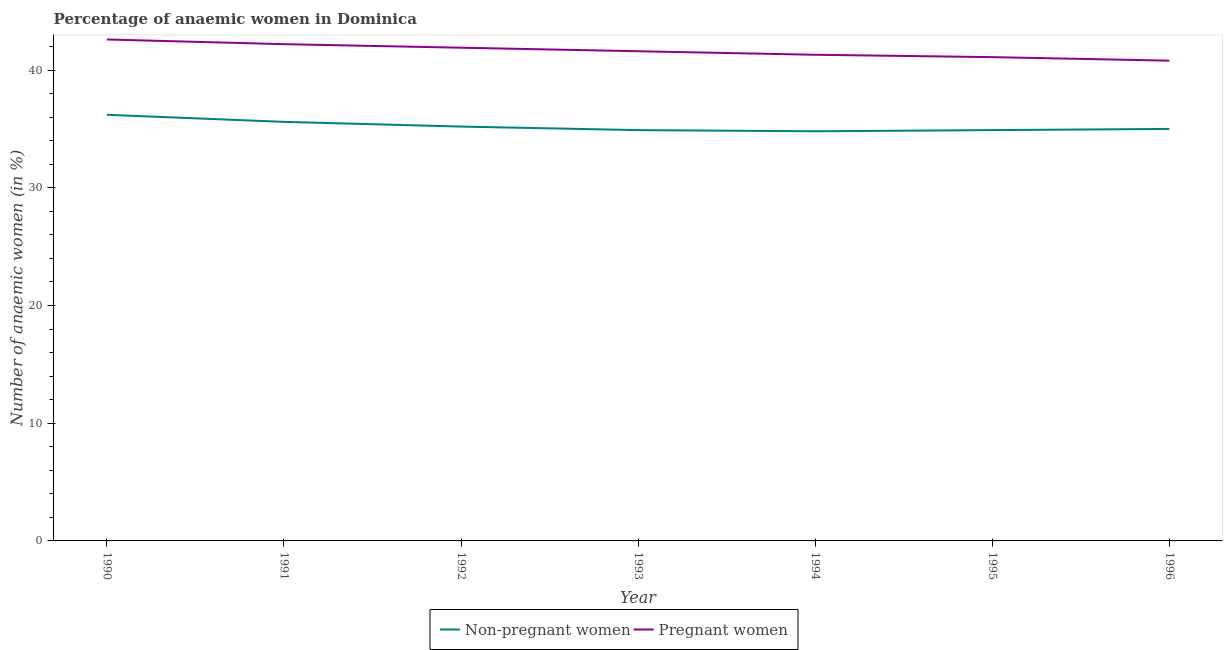How many different coloured lines are there?
Your response must be concise. 2. What is the percentage of pregnant anaemic women in 1991?
Provide a succinct answer. 42.2. Across all years, what is the maximum percentage of non-pregnant anaemic women?
Ensure brevity in your answer.  36.2. Across all years, what is the minimum percentage of non-pregnant anaemic women?
Give a very brief answer. 34.8. In which year was the percentage of non-pregnant anaemic women maximum?
Ensure brevity in your answer.  1990. In which year was the percentage of pregnant anaemic women minimum?
Your answer should be compact. 1996. What is the total percentage of pregnant anaemic women in the graph?
Make the answer very short. 291.5. What is the difference between the percentage of non-pregnant anaemic women in 1991 and that in 1996?
Your response must be concise. 0.6. What is the difference between the percentage of non-pregnant anaemic women in 1993 and the percentage of pregnant anaemic women in 1994?
Provide a succinct answer. -6.4. What is the average percentage of pregnant anaemic women per year?
Keep it short and to the point. 41.64. In the year 1995, what is the difference between the percentage of pregnant anaemic women and percentage of non-pregnant anaemic women?
Keep it short and to the point. 6.2. In how many years, is the percentage of pregnant anaemic women greater than 26 %?
Provide a succinct answer. 7. What is the ratio of the percentage of non-pregnant anaemic women in 1995 to that in 1996?
Ensure brevity in your answer.  1. Is the percentage of non-pregnant anaemic women in 1991 less than that in 1992?
Your response must be concise. No. Is the difference between the percentage of pregnant anaemic women in 1990 and 1991 greater than the difference between the percentage of non-pregnant anaemic women in 1990 and 1991?
Keep it short and to the point. No. What is the difference between the highest and the second highest percentage of non-pregnant anaemic women?
Provide a succinct answer. 0.6. What is the difference between the highest and the lowest percentage of non-pregnant anaemic women?
Offer a very short reply. 1.4. Is the sum of the percentage of pregnant anaemic women in 1992 and 1994 greater than the maximum percentage of non-pregnant anaemic women across all years?
Make the answer very short. Yes. Does the percentage of non-pregnant anaemic women monotonically increase over the years?
Keep it short and to the point. No. Is the percentage of non-pregnant anaemic women strictly greater than the percentage of pregnant anaemic women over the years?
Your answer should be compact. No. Is the percentage of non-pregnant anaemic women strictly less than the percentage of pregnant anaemic women over the years?
Provide a succinct answer. Yes. How many lines are there?
Your response must be concise. 2. What is the difference between two consecutive major ticks on the Y-axis?
Ensure brevity in your answer.  10. Are the values on the major ticks of Y-axis written in scientific E-notation?
Provide a succinct answer. No. Where does the legend appear in the graph?
Ensure brevity in your answer.  Bottom center. How are the legend labels stacked?
Offer a terse response. Horizontal. What is the title of the graph?
Your answer should be very brief. Percentage of anaemic women in Dominica. Does "Not attending school" appear as one of the legend labels in the graph?
Your response must be concise. No. What is the label or title of the Y-axis?
Your response must be concise. Number of anaemic women (in %). What is the Number of anaemic women (in %) of Non-pregnant women in 1990?
Your answer should be compact. 36.2. What is the Number of anaemic women (in %) of Pregnant women in 1990?
Keep it short and to the point. 42.6. What is the Number of anaemic women (in %) in Non-pregnant women in 1991?
Ensure brevity in your answer.  35.6. What is the Number of anaemic women (in %) in Pregnant women in 1991?
Provide a short and direct response. 42.2. What is the Number of anaemic women (in %) of Non-pregnant women in 1992?
Your answer should be very brief. 35.2. What is the Number of anaemic women (in %) in Pregnant women in 1992?
Your answer should be very brief. 41.9. What is the Number of anaemic women (in %) of Non-pregnant women in 1993?
Give a very brief answer. 34.9. What is the Number of anaemic women (in %) of Pregnant women in 1993?
Your response must be concise. 41.6. What is the Number of anaemic women (in %) in Non-pregnant women in 1994?
Make the answer very short. 34.8. What is the Number of anaemic women (in %) in Pregnant women in 1994?
Provide a short and direct response. 41.3. What is the Number of anaemic women (in %) in Non-pregnant women in 1995?
Offer a terse response. 34.9. What is the Number of anaemic women (in %) of Pregnant women in 1995?
Ensure brevity in your answer.  41.1. What is the Number of anaemic women (in %) in Non-pregnant women in 1996?
Provide a short and direct response. 35. What is the Number of anaemic women (in %) of Pregnant women in 1996?
Keep it short and to the point. 40.8. Across all years, what is the maximum Number of anaemic women (in %) in Non-pregnant women?
Your response must be concise. 36.2. Across all years, what is the maximum Number of anaemic women (in %) of Pregnant women?
Your answer should be very brief. 42.6. Across all years, what is the minimum Number of anaemic women (in %) in Non-pregnant women?
Keep it short and to the point. 34.8. Across all years, what is the minimum Number of anaemic women (in %) of Pregnant women?
Offer a terse response. 40.8. What is the total Number of anaemic women (in %) of Non-pregnant women in the graph?
Your response must be concise. 246.6. What is the total Number of anaemic women (in %) of Pregnant women in the graph?
Provide a short and direct response. 291.5. What is the difference between the Number of anaemic women (in %) of Non-pregnant women in 1990 and that in 1991?
Your response must be concise. 0.6. What is the difference between the Number of anaemic women (in %) in Pregnant women in 1990 and that in 1991?
Provide a short and direct response. 0.4. What is the difference between the Number of anaemic women (in %) of Non-pregnant women in 1990 and that in 1992?
Your answer should be very brief. 1. What is the difference between the Number of anaemic women (in %) of Pregnant women in 1990 and that in 1992?
Your response must be concise. 0.7. What is the difference between the Number of anaemic women (in %) in Pregnant women in 1990 and that in 1993?
Your response must be concise. 1. What is the difference between the Number of anaemic women (in %) of Non-pregnant women in 1990 and that in 1994?
Provide a short and direct response. 1.4. What is the difference between the Number of anaemic women (in %) of Non-pregnant women in 1990 and that in 1996?
Provide a short and direct response. 1.2. What is the difference between the Number of anaemic women (in %) of Pregnant women in 1991 and that in 1993?
Make the answer very short. 0.6. What is the difference between the Number of anaemic women (in %) in Non-pregnant women in 1991 and that in 1994?
Make the answer very short. 0.8. What is the difference between the Number of anaemic women (in %) of Non-pregnant women in 1991 and that in 1995?
Provide a short and direct response. 0.7. What is the difference between the Number of anaemic women (in %) in Non-pregnant women in 1991 and that in 1996?
Ensure brevity in your answer.  0.6. What is the difference between the Number of anaemic women (in %) in Pregnant women in 1991 and that in 1996?
Offer a very short reply. 1.4. What is the difference between the Number of anaemic women (in %) in Non-pregnant women in 1992 and that in 1994?
Your answer should be very brief. 0.4. What is the difference between the Number of anaemic women (in %) of Non-pregnant women in 1992 and that in 1995?
Offer a very short reply. 0.3. What is the difference between the Number of anaemic women (in %) in Non-pregnant women in 1992 and that in 1996?
Keep it short and to the point. 0.2. What is the difference between the Number of anaemic women (in %) of Pregnant women in 1992 and that in 1996?
Make the answer very short. 1.1. What is the difference between the Number of anaemic women (in %) in Non-pregnant women in 1994 and that in 1995?
Ensure brevity in your answer.  -0.1. What is the difference between the Number of anaemic women (in %) in Non-pregnant women in 1994 and that in 1996?
Offer a terse response. -0.2. What is the difference between the Number of anaemic women (in %) of Pregnant women in 1994 and that in 1996?
Give a very brief answer. 0.5. What is the difference between the Number of anaemic women (in %) in Non-pregnant women in 1995 and that in 1996?
Offer a terse response. -0.1. What is the difference between the Number of anaemic women (in %) in Pregnant women in 1995 and that in 1996?
Ensure brevity in your answer.  0.3. What is the difference between the Number of anaemic women (in %) of Non-pregnant women in 1990 and the Number of anaemic women (in %) of Pregnant women in 1992?
Provide a short and direct response. -5.7. What is the difference between the Number of anaemic women (in %) of Non-pregnant women in 1990 and the Number of anaemic women (in %) of Pregnant women in 1993?
Provide a succinct answer. -5.4. What is the difference between the Number of anaemic women (in %) in Non-pregnant women in 1990 and the Number of anaemic women (in %) in Pregnant women in 1995?
Give a very brief answer. -4.9. What is the difference between the Number of anaemic women (in %) of Non-pregnant women in 1990 and the Number of anaemic women (in %) of Pregnant women in 1996?
Ensure brevity in your answer.  -4.6. What is the difference between the Number of anaemic women (in %) of Non-pregnant women in 1991 and the Number of anaemic women (in %) of Pregnant women in 1993?
Provide a succinct answer. -6. What is the difference between the Number of anaemic women (in %) in Non-pregnant women in 1991 and the Number of anaemic women (in %) in Pregnant women in 1996?
Ensure brevity in your answer.  -5.2. What is the difference between the Number of anaemic women (in %) in Non-pregnant women in 1992 and the Number of anaemic women (in %) in Pregnant women in 1993?
Your answer should be very brief. -6.4. What is the difference between the Number of anaemic women (in %) of Non-pregnant women in 1992 and the Number of anaemic women (in %) of Pregnant women in 1994?
Your answer should be very brief. -6.1. What is the difference between the Number of anaemic women (in %) in Non-pregnant women in 1993 and the Number of anaemic women (in %) in Pregnant women in 1994?
Give a very brief answer. -6.4. What is the difference between the Number of anaemic women (in %) of Non-pregnant women in 1993 and the Number of anaemic women (in %) of Pregnant women in 1996?
Offer a very short reply. -5.9. What is the difference between the Number of anaemic women (in %) of Non-pregnant women in 1994 and the Number of anaemic women (in %) of Pregnant women in 1995?
Offer a terse response. -6.3. What is the average Number of anaemic women (in %) in Non-pregnant women per year?
Make the answer very short. 35.23. What is the average Number of anaemic women (in %) in Pregnant women per year?
Ensure brevity in your answer.  41.64. In the year 1990, what is the difference between the Number of anaemic women (in %) in Non-pregnant women and Number of anaemic women (in %) in Pregnant women?
Keep it short and to the point. -6.4. In the year 1991, what is the difference between the Number of anaemic women (in %) in Non-pregnant women and Number of anaemic women (in %) in Pregnant women?
Provide a short and direct response. -6.6. In the year 1993, what is the difference between the Number of anaemic women (in %) of Non-pregnant women and Number of anaemic women (in %) of Pregnant women?
Offer a terse response. -6.7. In the year 1995, what is the difference between the Number of anaemic women (in %) of Non-pregnant women and Number of anaemic women (in %) of Pregnant women?
Offer a very short reply. -6.2. What is the ratio of the Number of anaemic women (in %) in Non-pregnant women in 1990 to that in 1991?
Your answer should be compact. 1.02. What is the ratio of the Number of anaemic women (in %) in Pregnant women in 1990 to that in 1991?
Provide a short and direct response. 1.01. What is the ratio of the Number of anaemic women (in %) in Non-pregnant women in 1990 to that in 1992?
Your response must be concise. 1.03. What is the ratio of the Number of anaemic women (in %) in Pregnant women in 1990 to that in 1992?
Give a very brief answer. 1.02. What is the ratio of the Number of anaemic women (in %) in Non-pregnant women in 1990 to that in 1993?
Provide a succinct answer. 1.04. What is the ratio of the Number of anaemic women (in %) of Non-pregnant women in 1990 to that in 1994?
Your response must be concise. 1.04. What is the ratio of the Number of anaemic women (in %) in Pregnant women in 1990 to that in 1994?
Your answer should be very brief. 1.03. What is the ratio of the Number of anaemic women (in %) of Non-pregnant women in 1990 to that in 1995?
Offer a very short reply. 1.04. What is the ratio of the Number of anaemic women (in %) of Pregnant women in 1990 to that in 1995?
Your answer should be very brief. 1.04. What is the ratio of the Number of anaemic women (in %) in Non-pregnant women in 1990 to that in 1996?
Give a very brief answer. 1.03. What is the ratio of the Number of anaemic women (in %) of Pregnant women in 1990 to that in 1996?
Make the answer very short. 1.04. What is the ratio of the Number of anaemic women (in %) in Non-pregnant women in 1991 to that in 1992?
Provide a short and direct response. 1.01. What is the ratio of the Number of anaemic women (in %) of Pregnant women in 1991 to that in 1992?
Make the answer very short. 1.01. What is the ratio of the Number of anaemic women (in %) of Non-pregnant women in 1991 to that in 1993?
Offer a terse response. 1.02. What is the ratio of the Number of anaemic women (in %) in Pregnant women in 1991 to that in 1993?
Offer a very short reply. 1.01. What is the ratio of the Number of anaemic women (in %) of Non-pregnant women in 1991 to that in 1994?
Provide a short and direct response. 1.02. What is the ratio of the Number of anaemic women (in %) of Pregnant women in 1991 to that in 1994?
Offer a very short reply. 1.02. What is the ratio of the Number of anaemic women (in %) of Non-pregnant women in 1991 to that in 1995?
Offer a very short reply. 1.02. What is the ratio of the Number of anaemic women (in %) in Pregnant women in 1991 to that in 1995?
Provide a short and direct response. 1.03. What is the ratio of the Number of anaemic women (in %) in Non-pregnant women in 1991 to that in 1996?
Your answer should be compact. 1.02. What is the ratio of the Number of anaemic women (in %) of Pregnant women in 1991 to that in 1996?
Your response must be concise. 1.03. What is the ratio of the Number of anaemic women (in %) of Non-pregnant women in 1992 to that in 1993?
Give a very brief answer. 1.01. What is the ratio of the Number of anaemic women (in %) of Pregnant women in 1992 to that in 1993?
Make the answer very short. 1.01. What is the ratio of the Number of anaemic women (in %) of Non-pregnant women in 1992 to that in 1994?
Give a very brief answer. 1.01. What is the ratio of the Number of anaemic women (in %) in Pregnant women in 1992 to that in 1994?
Make the answer very short. 1.01. What is the ratio of the Number of anaemic women (in %) in Non-pregnant women in 1992 to that in 1995?
Offer a terse response. 1.01. What is the ratio of the Number of anaemic women (in %) of Pregnant women in 1992 to that in 1995?
Make the answer very short. 1.02. What is the ratio of the Number of anaemic women (in %) of Non-pregnant women in 1992 to that in 1996?
Give a very brief answer. 1.01. What is the ratio of the Number of anaemic women (in %) of Pregnant women in 1993 to that in 1994?
Ensure brevity in your answer.  1.01. What is the ratio of the Number of anaemic women (in %) in Pregnant women in 1993 to that in 1995?
Keep it short and to the point. 1.01. What is the ratio of the Number of anaemic women (in %) of Pregnant women in 1993 to that in 1996?
Offer a terse response. 1.02. What is the ratio of the Number of anaemic women (in %) of Pregnant women in 1994 to that in 1995?
Your answer should be compact. 1. What is the ratio of the Number of anaemic women (in %) in Non-pregnant women in 1994 to that in 1996?
Make the answer very short. 0.99. What is the ratio of the Number of anaemic women (in %) of Pregnant women in 1994 to that in 1996?
Make the answer very short. 1.01. What is the ratio of the Number of anaemic women (in %) of Non-pregnant women in 1995 to that in 1996?
Your answer should be very brief. 1. What is the ratio of the Number of anaemic women (in %) in Pregnant women in 1995 to that in 1996?
Make the answer very short. 1.01. What is the difference between the highest and the lowest Number of anaemic women (in %) in Non-pregnant women?
Your answer should be very brief. 1.4. What is the difference between the highest and the lowest Number of anaemic women (in %) in Pregnant women?
Offer a terse response. 1.8. 